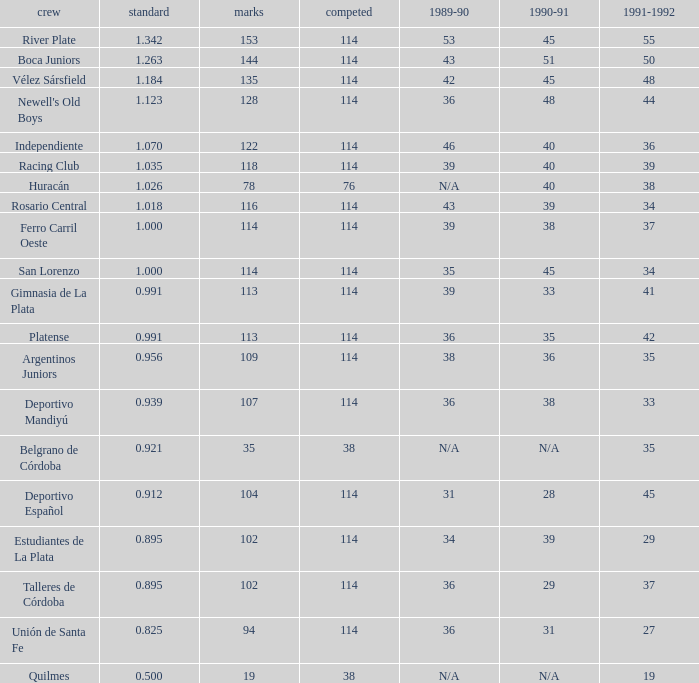How much Average has a 1989-90 of 36, and a Team of talleres de córdoba, and a Played smaller than 114? 0.0. 